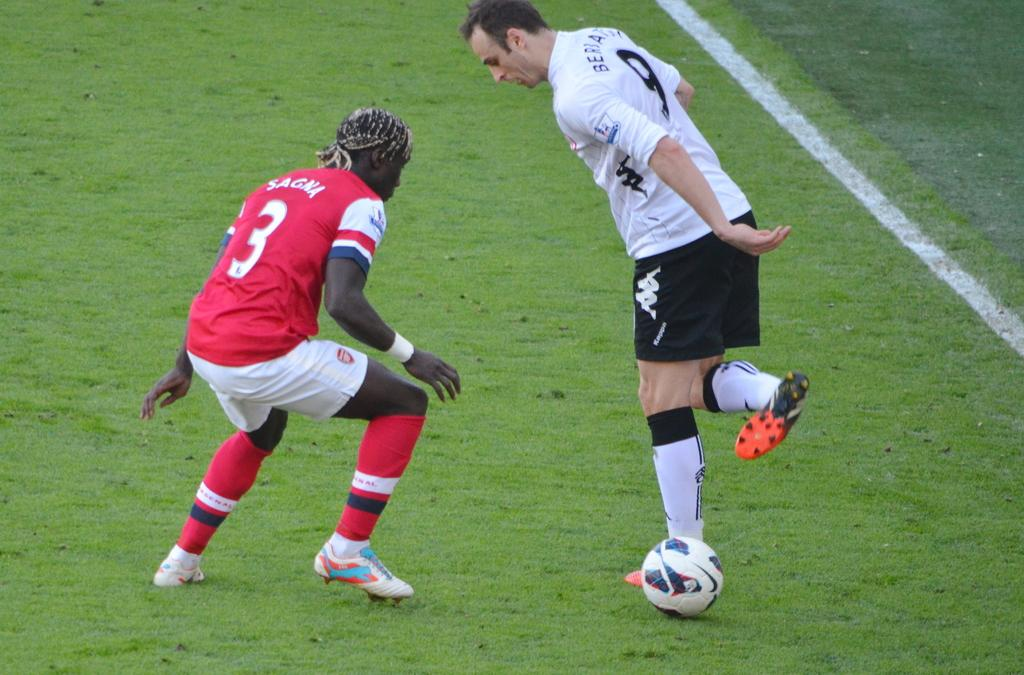How many people are in the image? There are two persons in the image. What is the ground like where the persons are standing? The persons are standing on a greenery ground. What object is beside the persons? There is a ball beside the persons. Can you describe any lines or markings in the image? There is a white line in the right corner of the image. How many pizzas are being served on the boats in the image? There are no boats or pizzas present in the image. What type of dime is visible on the ground in the image? There is no dime visible on the ground in the image. 